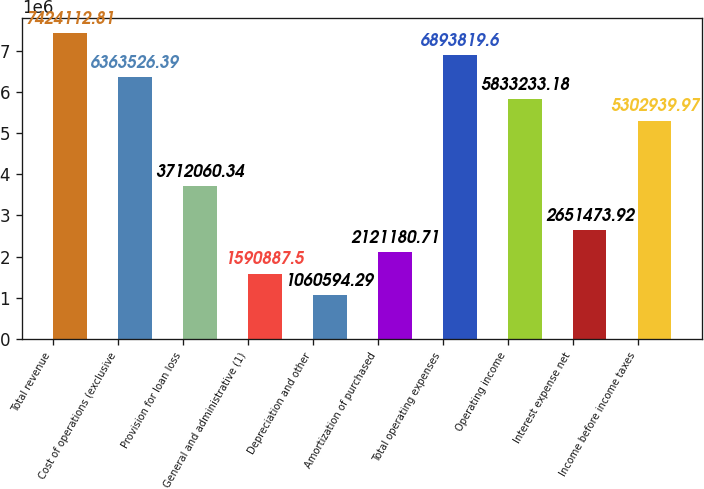<chart> <loc_0><loc_0><loc_500><loc_500><bar_chart><fcel>Total revenue<fcel>Cost of operations (exclusive<fcel>Provision for loan loss<fcel>General and administrative (1)<fcel>Depreciation and other<fcel>Amortization of purchased<fcel>Total operating expenses<fcel>Operating income<fcel>Interest expense net<fcel>Income before income taxes<nl><fcel>7.42411e+06<fcel>6.36353e+06<fcel>3.71206e+06<fcel>1.59089e+06<fcel>1.06059e+06<fcel>2.12118e+06<fcel>6.89382e+06<fcel>5.83323e+06<fcel>2.65147e+06<fcel>5.30294e+06<nl></chart> 